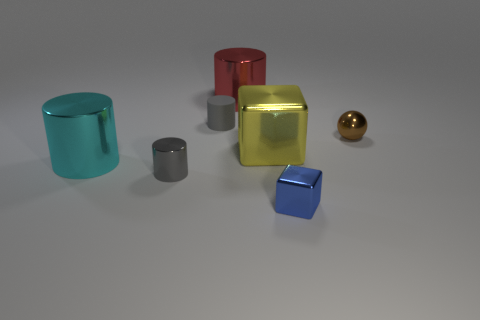Add 1 purple matte things. How many objects exist? 8 Subtract all cylinders. How many objects are left? 3 Add 4 green blocks. How many green blocks exist? 4 Subtract 0 purple balls. How many objects are left? 7 Subtract all large gray rubber cylinders. Subtract all brown things. How many objects are left? 6 Add 5 gray rubber things. How many gray rubber things are left? 6 